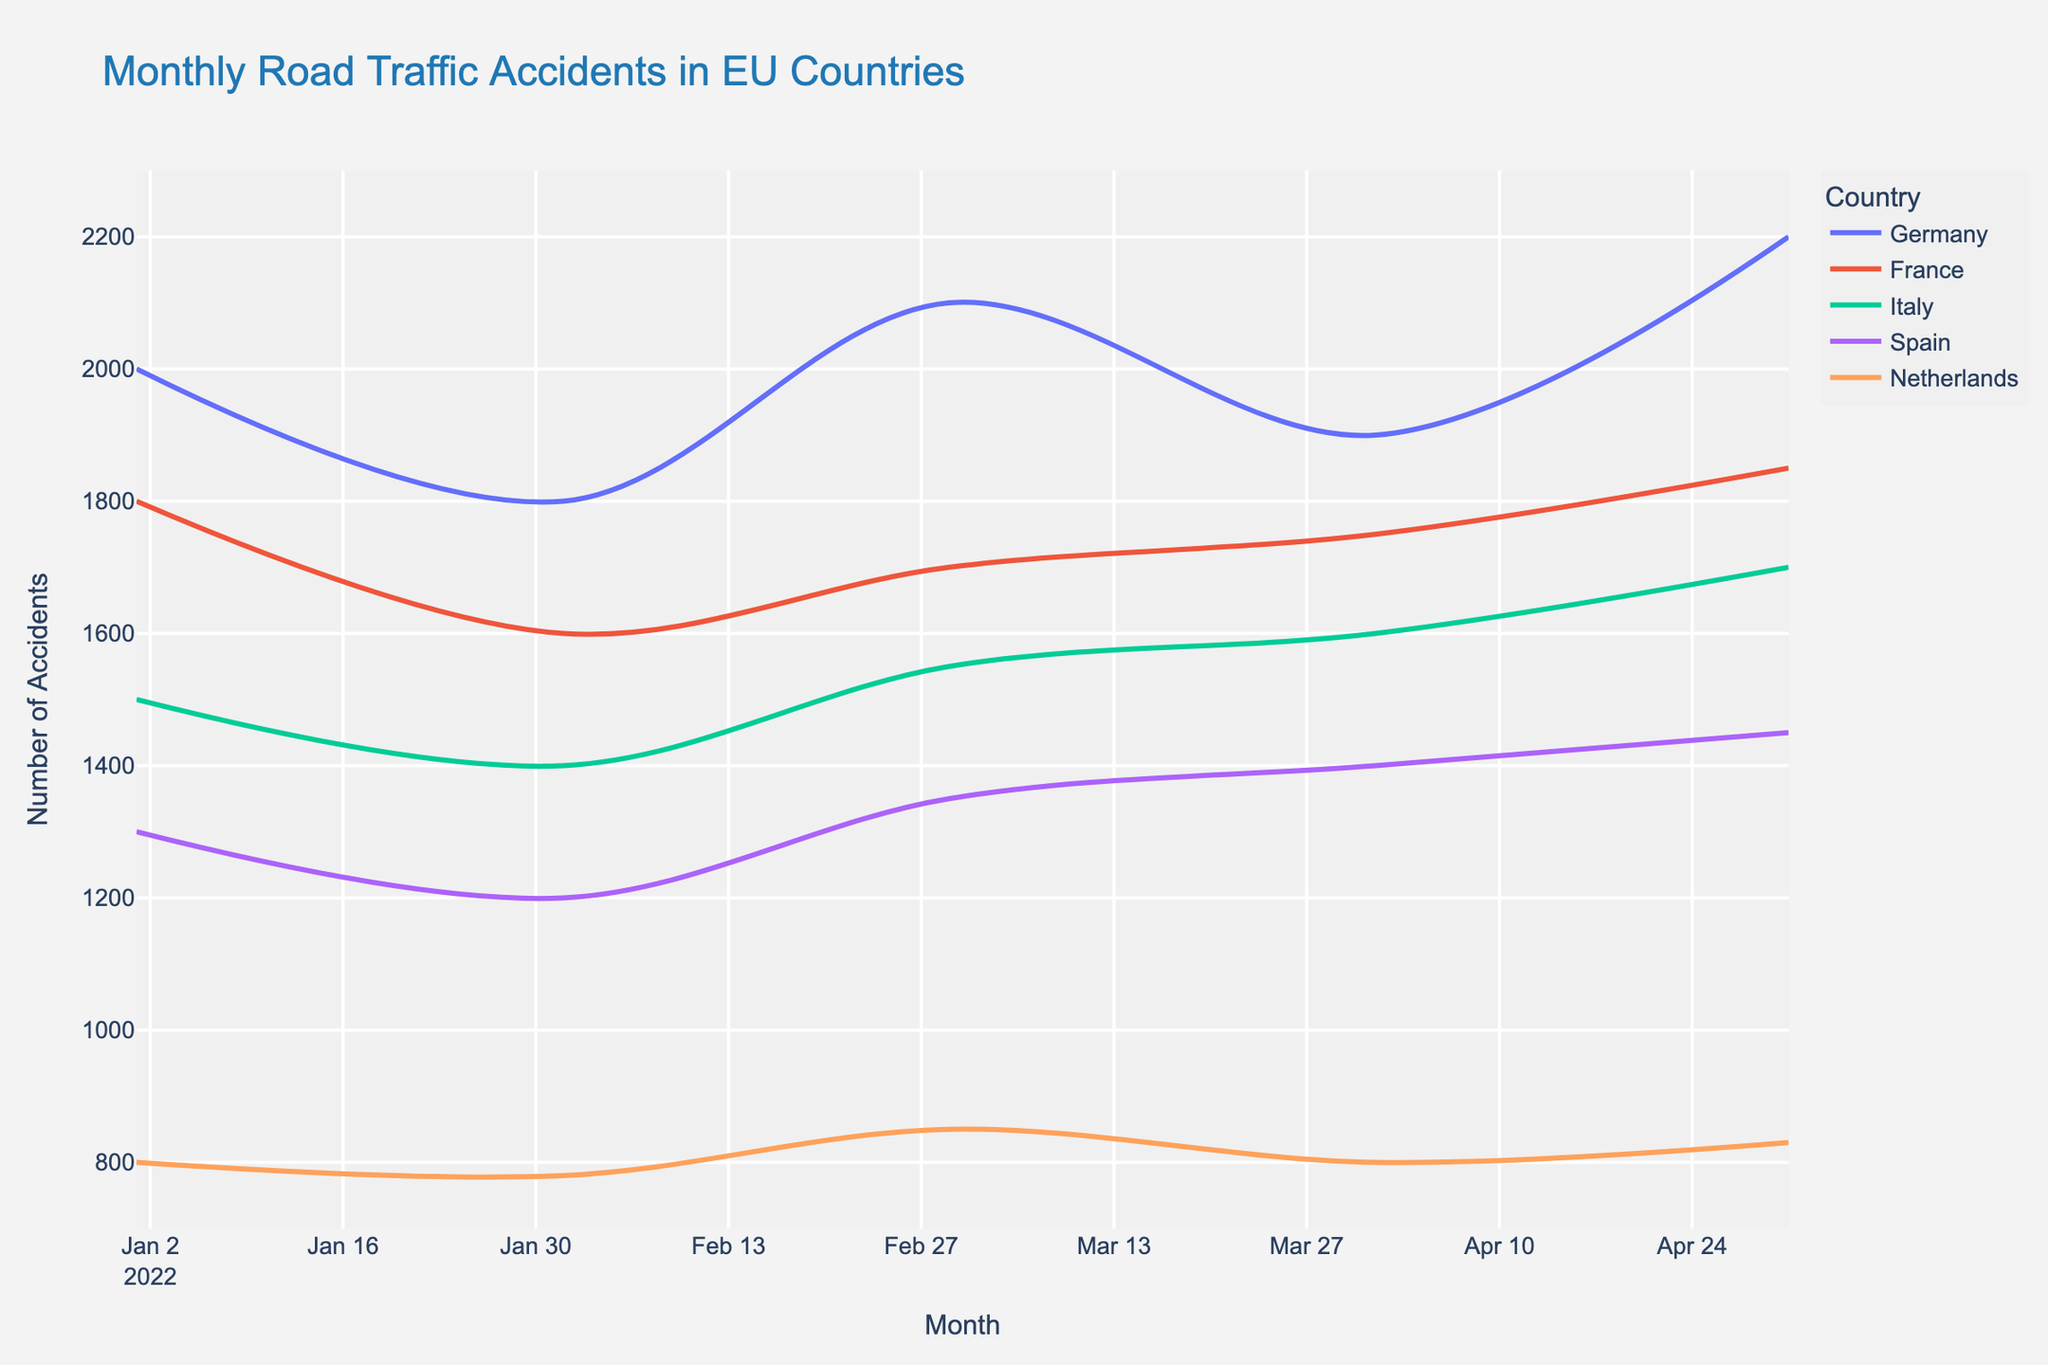What's the title of the plot? The title is displayed at the top of the plot.
Answer: Monthly Road Traffic Accidents in EU Countries Which country had the most road traffic accidents in March 2022? By looking at the March 2022 data points for each country, the highest value is Germany with 2100 accidents.
Answer: Germany How many accidents were there in Italy in February and March 2022 combined? Add the numbers for Italy in February (1400) and March (1550).
Answer: 2950 Which month had the highest average number of road accidents across all countries? Calculate the average for each month and compare them: January (2000+1800+1500+1300+800)/5 = 1480, February (1800+1600+1400+1200+780)/5 = 1356, March (2100+1700+1550+1350+850)/5 = 1510, April (1900+1750+1600+1400+800)/5 = 1490, May (2200+1850+1700+1450+830)/5 = 1606. May has the highest average.
Answer: May Which country had the least variation in the number of accidents from January to May 2022? Calculate the range (max value - min value) for each country and find the smallest one: Germany (2200-1800=400), France (1850-1600=250), Italy (1700-1400=300), Spain (1450-1200=250), Netherlands (850-780=70). The Netherlands has the least variation.
Answer: Netherlands Which two countries have the closest number of road traffic accidents in January 2022? Compare the numbers for January: Germany (2000), France (1800), Italy (1500), Spain (1300), Netherlands (800). France and Italy are closest with 300 difference.
Answer: France and Italy Did the number of road traffic accidents in Spain increase or decrease from March to April 2022, and by how much? Compare the values for Spain in March (1350) and April (1400), then find the difference. It increased by 50.
Answer: Increase by 50 In which month did France have the highest number of road traffic accidents? Look at the data for France: January (1800), February (1600), March (1700), April (1750), May (1850). The highest is in May with 1850 accidents.
Answer: May What is the trend observed in road traffic accidents in Germany from January to May 2022? Observe the direction of the line for Germany: January (2000), February (1800), March (2100), April (1900), May (2200). The numbers fluctuate but generally tend to increase towards May.
Answer: Fluctuating but generally increasing 